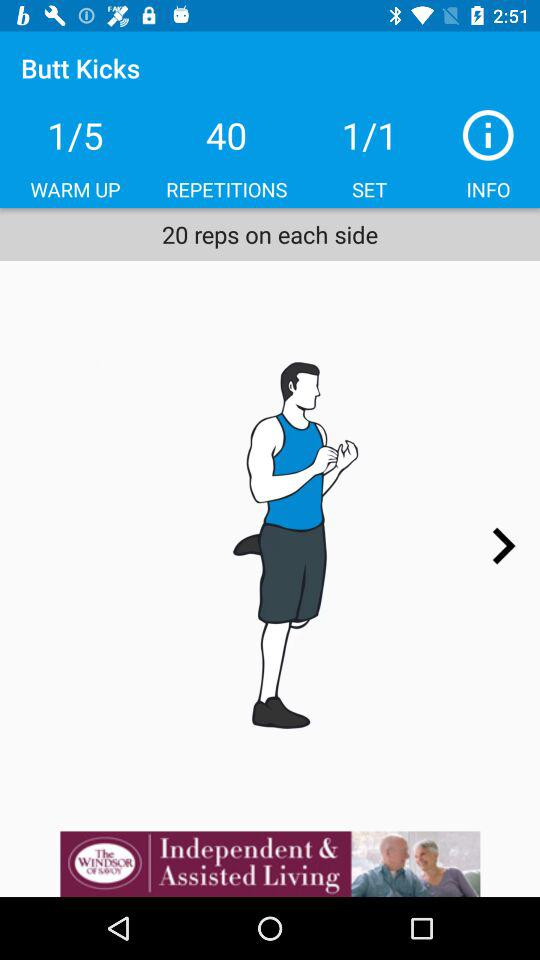How many sets are there? There is 1 set. 